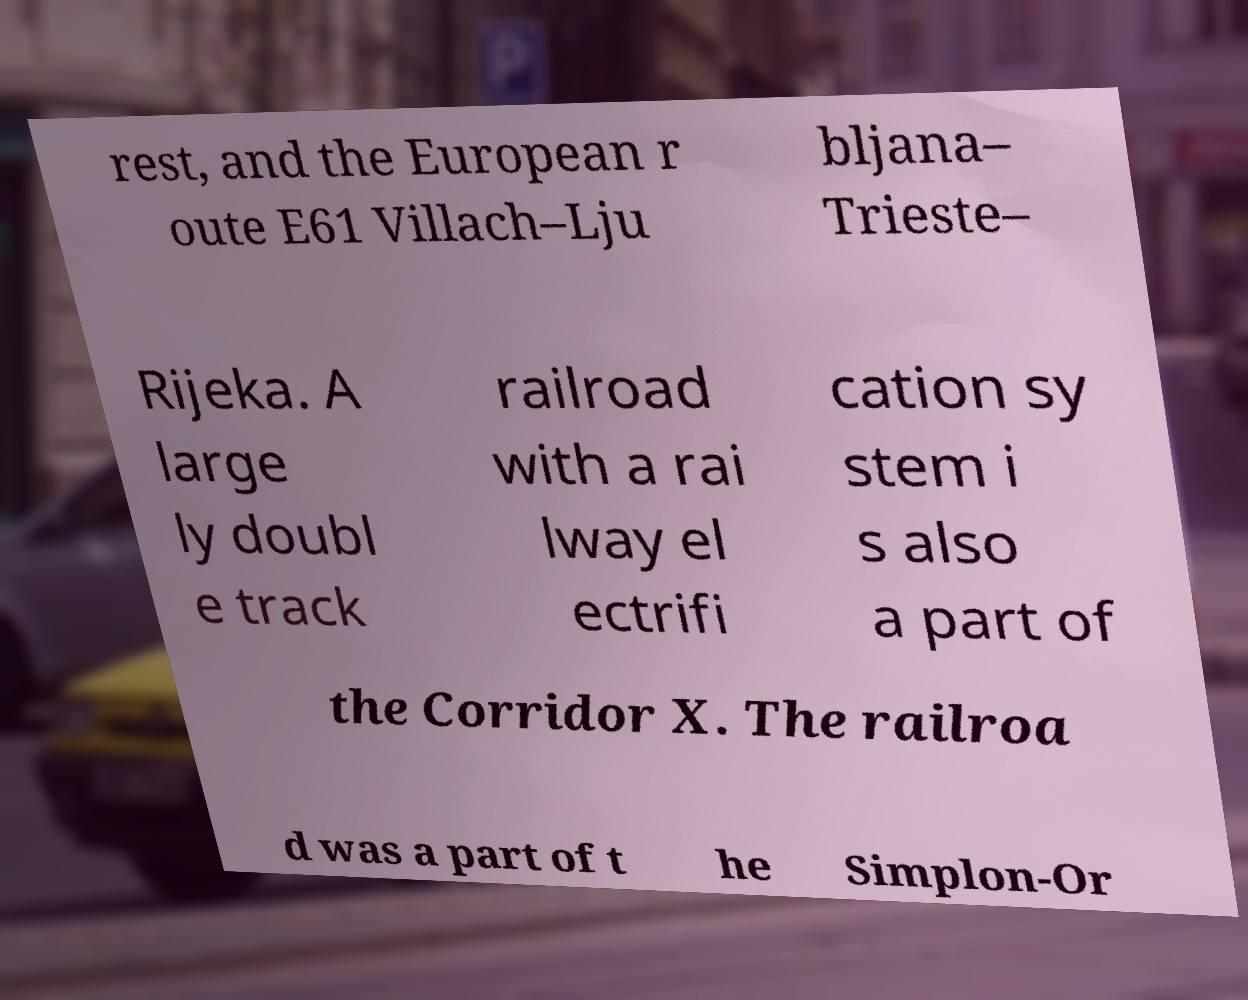Please read and relay the text visible in this image. What does it say? rest, and the European r oute E61 Villach–Lju bljana– Trieste– Rijeka. A large ly doubl e track railroad with a rai lway el ectrifi cation sy stem i s also a part of the Corridor X. The railroa d was a part of t he Simplon-Or 